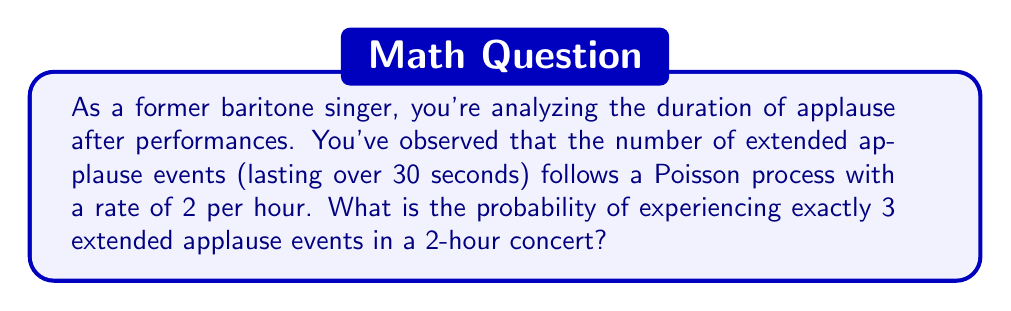Help me with this question. Let's approach this step-by-step:

1) We're dealing with a Poisson process, where:
   - The rate (λ) is 2 extended applause events per hour
   - The time period (t) is 2 hours
   - We're looking for the probability of exactly 3 events (k = 3)

2) The Poisson distribution formula is:

   $$P(X = k) = \frac{e^{-λt}(λt)^k}{k!}$$

   Where:
   - e is Euler's number (approximately 2.71828)
   - λ is the rate parameter
   - t is the time interval
   - k is the number of events we're interested in

3) Let's plug in our values:
   - λt = 2 events/hour * 2 hours = 4
   - k = 3

4) Now, let's calculate:

   $$P(X = 3) = \frac{e^{-4}(4)^3}{3!}$$

5) Simplify:
   $$P(X = 3) = \frac{e^{-4} * 64}{6}$$

6) Calculate:
   $$P(X = 3) ≈ \frac{0.0183 * 64}{6} ≈ 0.1954$$

7) Convert to a percentage:
   0.1954 * 100% ≈ 19.54%

Thus, the probability of experiencing exactly 3 extended applause events in a 2-hour concert is approximately 19.54%.
Answer: 19.54% 